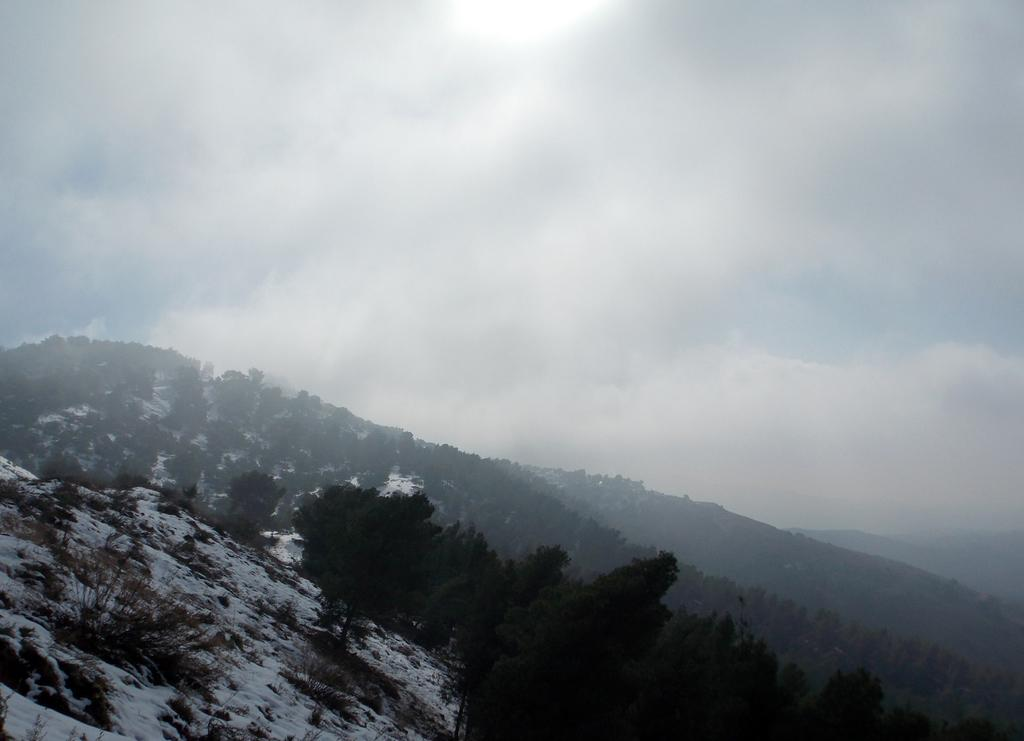What type of geographical feature is present in the image? There are mountains in the image. What is the condition of the mountains in the image? The mountains have snow visible on them. Are there any plants on the mountains in the image? Yes, there are trees on the mountains. What can be seen in the background of the image? The sky is visible in the background of the image. What type of sign can be seen on the mountain in the image? There is no sign present on the mountain in the image. What angle is the vase tilted at in the image? There is no vase present in the image. 